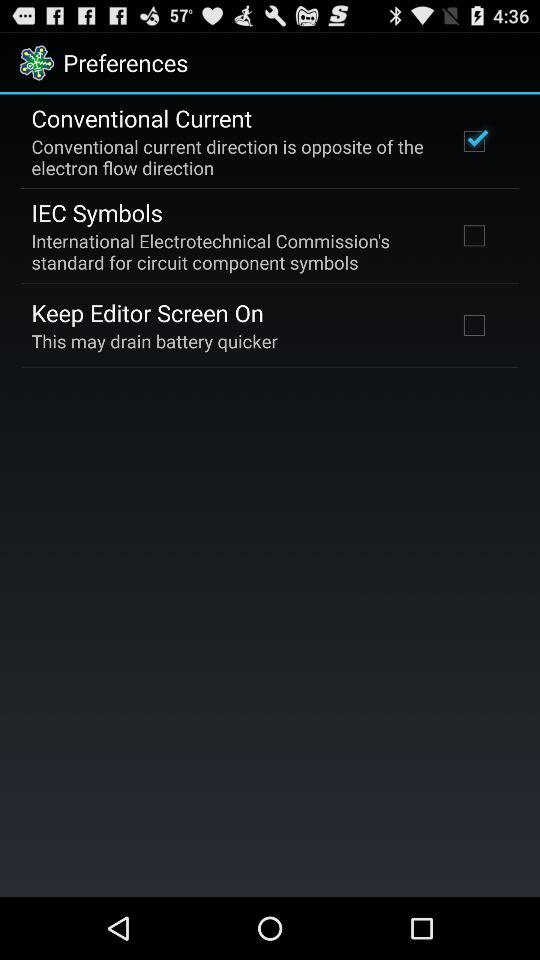What's the name of the Commission's standard for circuit component symbols? The name of the Commission's standard for circuit component symbols is "International Electrotechnical Commission's". 